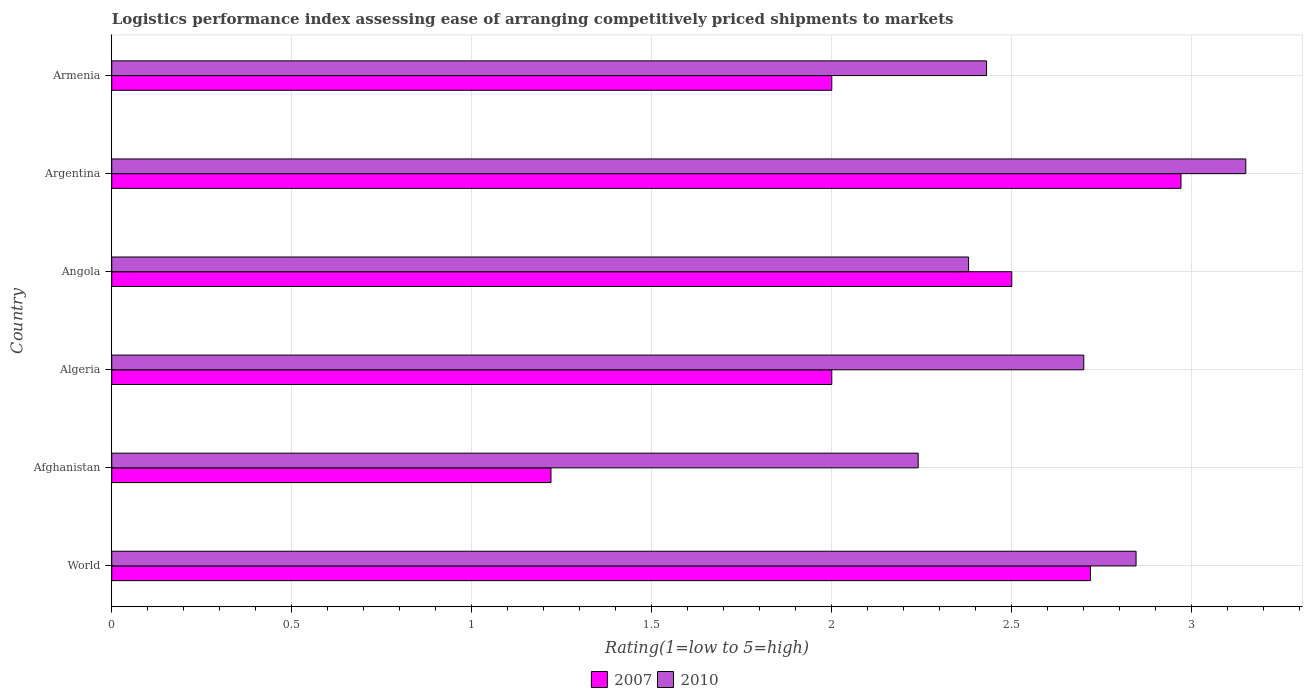How many groups of bars are there?
Give a very brief answer. 6. Are the number of bars per tick equal to the number of legend labels?
Offer a terse response. Yes. How many bars are there on the 4th tick from the top?
Your response must be concise. 2. What is the label of the 1st group of bars from the top?
Make the answer very short. Armenia. In how many cases, is the number of bars for a given country not equal to the number of legend labels?
Offer a terse response. 0. Across all countries, what is the maximum Logistic performance index in 2007?
Your answer should be compact. 2.97. Across all countries, what is the minimum Logistic performance index in 2010?
Your response must be concise. 2.24. In which country was the Logistic performance index in 2010 maximum?
Offer a terse response. Argentina. In which country was the Logistic performance index in 2007 minimum?
Keep it short and to the point. Afghanistan. What is the total Logistic performance index in 2010 in the graph?
Offer a very short reply. 15.75. What is the difference between the Logistic performance index in 2010 in Angola and that in World?
Your answer should be very brief. -0.47. What is the difference between the Logistic performance index in 2010 in Armenia and the Logistic performance index in 2007 in Algeria?
Keep it short and to the point. 0.43. What is the average Logistic performance index in 2007 per country?
Make the answer very short. 2.23. What is the difference between the Logistic performance index in 2007 and Logistic performance index in 2010 in Armenia?
Give a very brief answer. -0.43. What is the ratio of the Logistic performance index in 2007 in Algeria to that in World?
Make the answer very short. 0.74. Is the Logistic performance index in 2007 in Argentina less than that in Armenia?
Offer a very short reply. No. What is the difference between the highest and the second highest Logistic performance index in 2007?
Provide a short and direct response. 0.25. What is the difference between the highest and the lowest Logistic performance index in 2007?
Your answer should be very brief. 1.75. Are all the bars in the graph horizontal?
Your response must be concise. Yes. What is the difference between two consecutive major ticks on the X-axis?
Provide a succinct answer. 0.5. How many legend labels are there?
Your answer should be very brief. 2. How are the legend labels stacked?
Provide a short and direct response. Horizontal. What is the title of the graph?
Ensure brevity in your answer.  Logistics performance index assessing ease of arranging competitively priced shipments to markets. Does "1984" appear as one of the legend labels in the graph?
Your answer should be compact. No. What is the label or title of the X-axis?
Ensure brevity in your answer.  Rating(1=low to 5=high). What is the label or title of the Y-axis?
Your response must be concise. Country. What is the Rating(1=low to 5=high) in 2007 in World?
Provide a succinct answer. 2.72. What is the Rating(1=low to 5=high) of 2010 in World?
Ensure brevity in your answer.  2.85. What is the Rating(1=low to 5=high) of 2007 in Afghanistan?
Offer a terse response. 1.22. What is the Rating(1=low to 5=high) of 2010 in Afghanistan?
Your response must be concise. 2.24. What is the Rating(1=low to 5=high) of 2007 in Algeria?
Offer a very short reply. 2. What is the Rating(1=low to 5=high) of 2010 in Angola?
Make the answer very short. 2.38. What is the Rating(1=low to 5=high) of 2007 in Argentina?
Offer a very short reply. 2.97. What is the Rating(1=low to 5=high) of 2010 in Argentina?
Your answer should be compact. 3.15. What is the Rating(1=low to 5=high) of 2010 in Armenia?
Keep it short and to the point. 2.43. Across all countries, what is the maximum Rating(1=low to 5=high) of 2007?
Give a very brief answer. 2.97. Across all countries, what is the maximum Rating(1=low to 5=high) in 2010?
Provide a succinct answer. 3.15. Across all countries, what is the minimum Rating(1=low to 5=high) of 2007?
Ensure brevity in your answer.  1.22. Across all countries, what is the minimum Rating(1=low to 5=high) of 2010?
Provide a short and direct response. 2.24. What is the total Rating(1=low to 5=high) in 2007 in the graph?
Your response must be concise. 13.41. What is the total Rating(1=low to 5=high) of 2010 in the graph?
Your response must be concise. 15.75. What is the difference between the Rating(1=low to 5=high) of 2007 in World and that in Afghanistan?
Provide a short and direct response. 1.5. What is the difference between the Rating(1=low to 5=high) of 2010 in World and that in Afghanistan?
Offer a terse response. 0.61. What is the difference between the Rating(1=low to 5=high) of 2007 in World and that in Algeria?
Make the answer very short. 0.72. What is the difference between the Rating(1=low to 5=high) in 2010 in World and that in Algeria?
Make the answer very short. 0.15. What is the difference between the Rating(1=low to 5=high) in 2007 in World and that in Angola?
Offer a terse response. 0.22. What is the difference between the Rating(1=low to 5=high) in 2010 in World and that in Angola?
Provide a short and direct response. 0.47. What is the difference between the Rating(1=low to 5=high) in 2007 in World and that in Argentina?
Give a very brief answer. -0.25. What is the difference between the Rating(1=low to 5=high) of 2010 in World and that in Argentina?
Make the answer very short. -0.3. What is the difference between the Rating(1=low to 5=high) in 2007 in World and that in Armenia?
Offer a very short reply. 0.72. What is the difference between the Rating(1=low to 5=high) of 2010 in World and that in Armenia?
Your answer should be compact. 0.42. What is the difference between the Rating(1=low to 5=high) in 2007 in Afghanistan and that in Algeria?
Your answer should be very brief. -0.78. What is the difference between the Rating(1=low to 5=high) in 2010 in Afghanistan and that in Algeria?
Give a very brief answer. -0.46. What is the difference between the Rating(1=low to 5=high) of 2007 in Afghanistan and that in Angola?
Offer a very short reply. -1.28. What is the difference between the Rating(1=low to 5=high) in 2010 in Afghanistan and that in Angola?
Keep it short and to the point. -0.14. What is the difference between the Rating(1=low to 5=high) in 2007 in Afghanistan and that in Argentina?
Provide a short and direct response. -1.75. What is the difference between the Rating(1=low to 5=high) of 2010 in Afghanistan and that in Argentina?
Your response must be concise. -0.91. What is the difference between the Rating(1=low to 5=high) in 2007 in Afghanistan and that in Armenia?
Ensure brevity in your answer.  -0.78. What is the difference between the Rating(1=low to 5=high) in 2010 in Afghanistan and that in Armenia?
Ensure brevity in your answer.  -0.19. What is the difference between the Rating(1=low to 5=high) in 2010 in Algeria and that in Angola?
Make the answer very short. 0.32. What is the difference between the Rating(1=low to 5=high) of 2007 in Algeria and that in Argentina?
Provide a short and direct response. -0.97. What is the difference between the Rating(1=low to 5=high) of 2010 in Algeria and that in Argentina?
Your answer should be very brief. -0.45. What is the difference between the Rating(1=low to 5=high) of 2010 in Algeria and that in Armenia?
Ensure brevity in your answer.  0.27. What is the difference between the Rating(1=low to 5=high) of 2007 in Angola and that in Argentina?
Offer a terse response. -0.47. What is the difference between the Rating(1=low to 5=high) in 2010 in Angola and that in Argentina?
Offer a very short reply. -0.77. What is the difference between the Rating(1=low to 5=high) in 2007 in Angola and that in Armenia?
Your response must be concise. 0.5. What is the difference between the Rating(1=low to 5=high) of 2010 in Argentina and that in Armenia?
Offer a very short reply. 0.72. What is the difference between the Rating(1=low to 5=high) of 2007 in World and the Rating(1=low to 5=high) of 2010 in Afghanistan?
Ensure brevity in your answer.  0.48. What is the difference between the Rating(1=low to 5=high) in 2007 in World and the Rating(1=low to 5=high) in 2010 in Algeria?
Ensure brevity in your answer.  0.02. What is the difference between the Rating(1=low to 5=high) of 2007 in World and the Rating(1=low to 5=high) of 2010 in Angola?
Your answer should be compact. 0.34. What is the difference between the Rating(1=low to 5=high) in 2007 in World and the Rating(1=low to 5=high) in 2010 in Argentina?
Make the answer very short. -0.43. What is the difference between the Rating(1=low to 5=high) of 2007 in World and the Rating(1=low to 5=high) of 2010 in Armenia?
Make the answer very short. 0.29. What is the difference between the Rating(1=low to 5=high) of 2007 in Afghanistan and the Rating(1=low to 5=high) of 2010 in Algeria?
Your answer should be compact. -1.48. What is the difference between the Rating(1=low to 5=high) of 2007 in Afghanistan and the Rating(1=low to 5=high) of 2010 in Angola?
Provide a short and direct response. -1.16. What is the difference between the Rating(1=low to 5=high) of 2007 in Afghanistan and the Rating(1=low to 5=high) of 2010 in Argentina?
Offer a terse response. -1.93. What is the difference between the Rating(1=low to 5=high) of 2007 in Afghanistan and the Rating(1=low to 5=high) of 2010 in Armenia?
Ensure brevity in your answer.  -1.21. What is the difference between the Rating(1=low to 5=high) in 2007 in Algeria and the Rating(1=low to 5=high) in 2010 in Angola?
Give a very brief answer. -0.38. What is the difference between the Rating(1=low to 5=high) in 2007 in Algeria and the Rating(1=low to 5=high) in 2010 in Argentina?
Your response must be concise. -1.15. What is the difference between the Rating(1=low to 5=high) of 2007 in Algeria and the Rating(1=low to 5=high) of 2010 in Armenia?
Provide a succinct answer. -0.43. What is the difference between the Rating(1=low to 5=high) in 2007 in Angola and the Rating(1=low to 5=high) in 2010 in Argentina?
Your response must be concise. -0.65. What is the difference between the Rating(1=low to 5=high) in 2007 in Angola and the Rating(1=low to 5=high) in 2010 in Armenia?
Give a very brief answer. 0.07. What is the difference between the Rating(1=low to 5=high) of 2007 in Argentina and the Rating(1=low to 5=high) of 2010 in Armenia?
Your answer should be very brief. 0.54. What is the average Rating(1=low to 5=high) of 2007 per country?
Your response must be concise. 2.23. What is the average Rating(1=low to 5=high) of 2010 per country?
Offer a terse response. 2.62. What is the difference between the Rating(1=low to 5=high) in 2007 and Rating(1=low to 5=high) in 2010 in World?
Ensure brevity in your answer.  -0.13. What is the difference between the Rating(1=low to 5=high) of 2007 and Rating(1=low to 5=high) of 2010 in Afghanistan?
Offer a terse response. -1.02. What is the difference between the Rating(1=low to 5=high) in 2007 and Rating(1=low to 5=high) in 2010 in Algeria?
Your answer should be very brief. -0.7. What is the difference between the Rating(1=low to 5=high) in 2007 and Rating(1=low to 5=high) in 2010 in Angola?
Offer a very short reply. 0.12. What is the difference between the Rating(1=low to 5=high) in 2007 and Rating(1=low to 5=high) in 2010 in Argentina?
Make the answer very short. -0.18. What is the difference between the Rating(1=low to 5=high) of 2007 and Rating(1=low to 5=high) of 2010 in Armenia?
Your response must be concise. -0.43. What is the ratio of the Rating(1=low to 5=high) in 2007 in World to that in Afghanistan?
Make the answer very short. 2.23. What is the ratio of the Rating(1=low to 5=high) of 2010 in World to that in Afghanistan?
Offer a terse response. 1.27. What is the ratio of the Rating(1=low to 5=high) of 2007 in World to that in Algeria?
Ensure brevity in your answer.  1.36. What is the ratio of the Rating(1=low to 5=high) of 2010 in World to that in Algeria?
Provide a succinct answer. 1.05. What is the ratio of the Rating(1=low to 5=high) of 2007 in World to that in Angola?
Keep it short and to the point. 1.09. What is the ratio of the Rating(1=low to 5=high) of 2010 in World to that in Angola?
Your answer should be compact. 1.2. What is the ratio of the Rating(1=low to 5=high) in 2007 in World to that in Argentina?
Give a very brief answer. 0.92. What is the ratio of the Rating(1=low to 5=high) of 2010 in World to that in Argentina?
Your answer should be very brief. 0.9. What is the ratio of the Rating(1=low to 5=high) of 2007 in World to that in Armenia?
Offer a terse response. 1.36. What is the ratio of the Rating(1=low to 5=high) in 2010 in World to that in Armenia?
Your answer should be very brief. 1.17. What is the ratio of the Rating(1=low to 5=high) of 2007 in Afghanistan to that in Algeria?
Make the answer very short. 0.61. What is the ratio of the Rating(1=low to 5=high) in 2010 in Afghanistan to that in Algeria?
Keep it short and to the point. 0.83. What is the ratio of the Rating(1=low to 5=high) in 2007 in Afghanistan to that in Angola?
Ensure brevity in your answer.  0.49. What is the ratio of the Rating(1=low to 5=high) of 2010 in Afghanistan to that in Angola?
Provide a short and direct response. 0.94. What is the ratio of the Rating(1=low to 5=high) of 2007 in Afghanistan to that in Argentina?
Keep it short and to the point. 0.41. What is the ratio of the Rating(1=low to 5=high) of 2010 in Afghanistan to that in Argentina?
Provide a succinct answer. 0.71. What is the ratio of the Rating(1=low to 5=high) in 2007 in Afghanistan to that in Armenia?
Provide a short and direct response. 0.61. What is the ratio of the Rating(1=low to 5=high) of 2010 in Afghanistan to that in Armenia?
Your response must be concise. 0.92. What is the ratio of the Rating(1=low to 5=high) in 2010 in Algeria to that in Angola?
Offer a very short reply. 1.13. What is the ratio of the Rating(1=low to 5=high) in 2007 in Algeria to that in Argentina?
Keep it short and to the point. 0.67. What is the ratio of the Rating(1=low to 5=high) in 2010 in Algeria to that in Argentina?
Give a very brief answer. 0.86. What is the ratio of the Rating(1=low to 5=high) of 2007 in Angola to that in Argentina?
Make the answer very short. 0.84. What is the ratio of the Rating(1=low to 5=high) of 2010 in Angola to that in Argentina?
Your answer should be very brief. 0.76. What is the ratio of the Rating(1=low to 5=high) in 2010 in Angola to that in Armenia?
Make the answer very short. 0.98. What is the ratio of the Rating(1=low to 5=high) in 2007 in Argentina to that in Armenia?
Your answer should be very brief. 1.49. What is the ratio of the Rating(1=low to 5=high) in 2010 in Argentina to that in Armenia?
Your answer should be compact. 1.3. What is the difference between the highest and the second highest Rating(1=low to 5=high) of 2007?
Give a very brief answer. 0.25. What is the difference between the highest and the second highest Rating(1=low to 5=high) in 2010?
Provide a short and direct response. 0.3. What is the difference between the highest and the lowest Rating(1=low to 5=high) in 2010?
Provide a succinct answer. 0.91. 